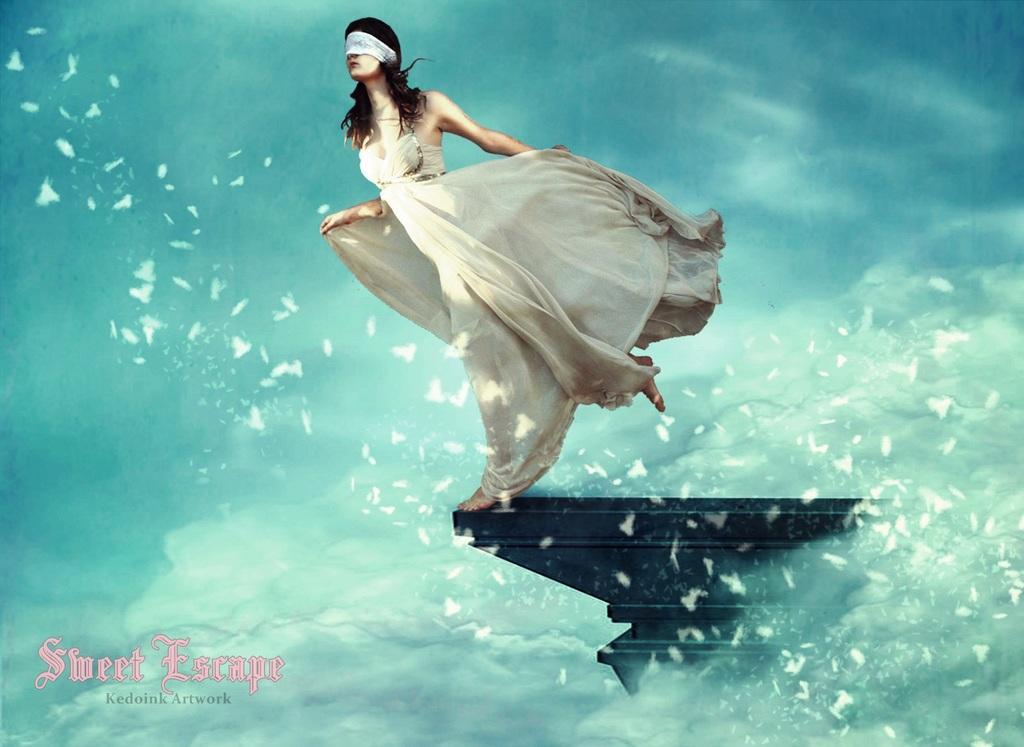How would you summarize this image in a sentence or two? In this image I can see the person wearing the cream color dress and standing on the black color object. I can see the person is blindfolded. And there is a blue and white color background. I can see this is an edited image. 